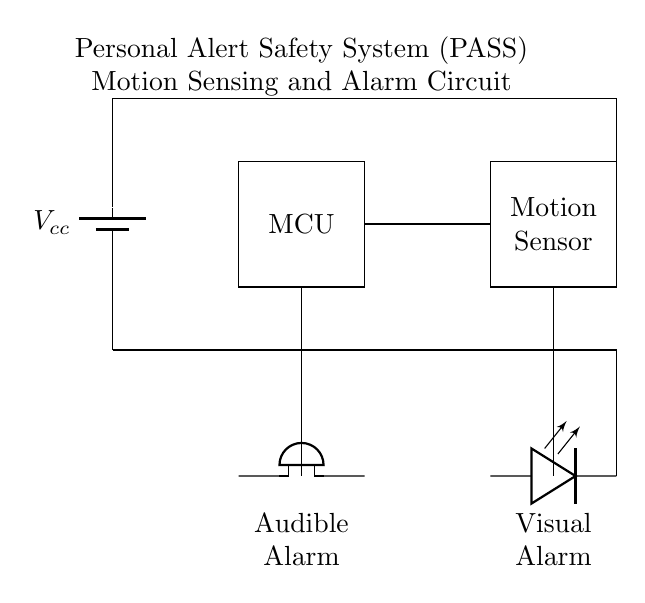What is the main component that detects motion? The main component responsible for detecting motion in the circuit is the motion sensor, as indicated by its label in the diagram.
Answer: Motion sensor What type of alarm is represented in the circuit? The circuit includes two types of alarms: an audible alarm (represented by the buzzer) and a visual alarm (represented by the LED).
Answer: Audible and visual How many power supply connections are present in the circuit? There are two power supply connections shown in the circuit. One source provides voltage to the microcontroller and the other to the motion sensor, as the circuit is split into powering both types of devices.
Answer: Two What connects the microcontroller to the motion sensor? A direct wire connection is indicated, which allows for data or control signals to transfer between the microcontroller and the motion sensor.
Answer: Wire connection What component is responsible for sound output in the circuit? The component responsible for sound output is the buzzer, which provides the audible alert when motion is detected by the motion sensor.
Answer: Buzzer What does the LED indicate in this circuit? The LED acts as a visual indicator, likely illuminating when the system is active or when motion is detected, providing a visual alarm.
Answer: Visual alarm Why is a microcontroller used in this circuit? The microcontroller serves as the control unit that processes signals from the motion sensor and activates the alarms accordingly, making it essential for the operation of the PASS device.
Answer: Control unit 